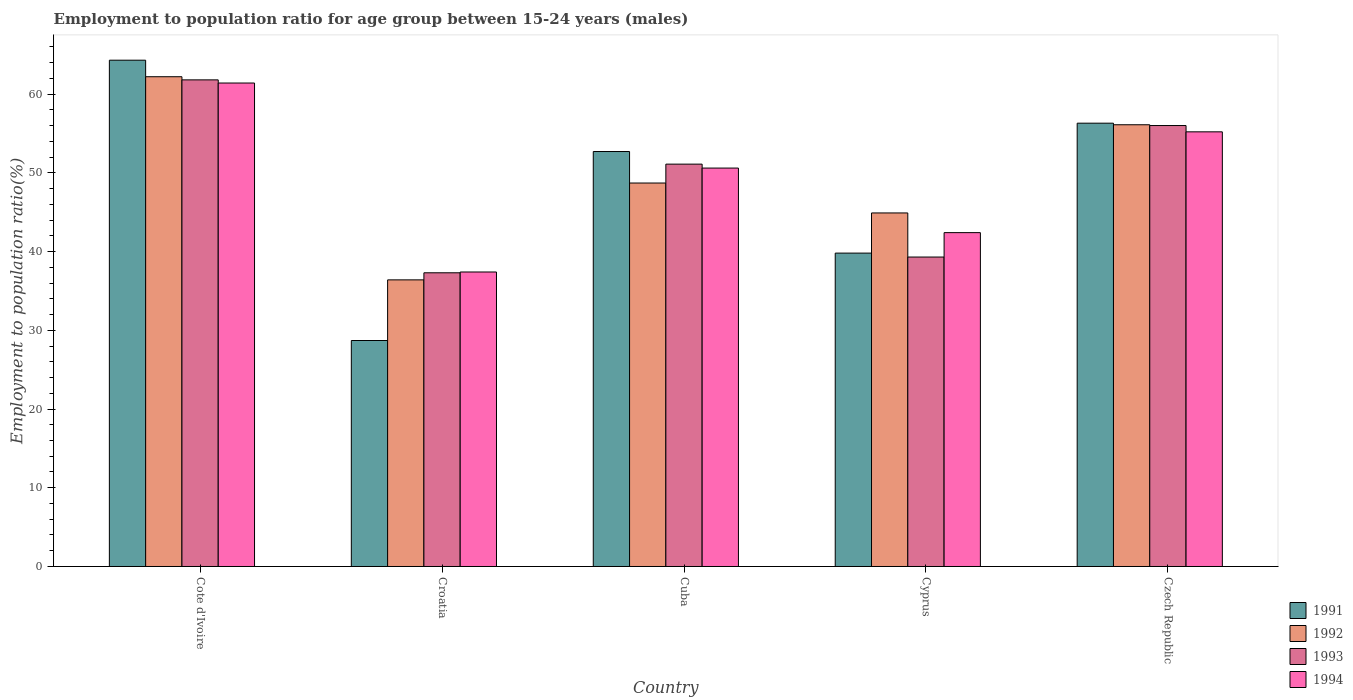How many different coloured bars are there?
Ensure brevity in your answer.  4. Are the number of bars on each tick of the X-axis equal?
Your answer should be very brief. Yes. How many bars are there on the 2nd tick from the right?
Ensure brevity in your answer.  4. What is the label of the 1st group of bars from the left?
Offer a very short reply. Cote d'Ivoire. What is the employment to population ratio in 1994 in Czech Republic?
Your answer should be very brief. 55.2. Across all countries, what is the maximum employment to population ratio in 1994?
Ensure brevity in your answer.  61.4. Across all countries, what is the minimum employment to population ratio in 1993?
Provide a succinct answer. 37.3. In which country was the employment to population ratio in 1993 maximum?
Keep it short and to the point. Cote d'Ivoire. In which country was the employment to population ratio in 1994 minimum?
Provide a succinct answer. Croatia. What is the total employment to population ratio in 1993 in the graph?
Ensure brevity in your answer.  245.5. What is the difference between the employment to population ratio in 1991 in Cote d'Ivoire and that in Croatia?
Provide a short and direct response. 35.6. What is the difference between the employment to population ratio in 1991 in Cuba and the employment to population ratio in 1993 in Czech Republic?
Keep it short and to the point. -3.3. What is the average employment to population ratio in 1992 per country?
Offer a terse response. 49.66. What is the difference between the employment to population ratio of/in 1992 and employment to population ratio of/in 1991 in Cuba?
Provide a short and direct response. -4. What is the ratio of the employment to population ratio in 1994 in Cote d'Ivoire to that in Croatia?
Ensure brevity in your answer.  1.64. Is the difference between the employment to population ratio in 1992 in Cyprus and Czech Republic greater than the difference between the employment to population ratio in 1991 in Cyprus and Czech Republic?
Offer a terse response. Yes. What is the difference between the highest and the second highest employment to population ratio in 1993?
Offer a very short reply. 4.9. What is the difference between the highest and the lowest employment to population ratio in 1993?
Your answer should be compact. 24.5. In how many countries, is the employment to population ratio in 1992 greater than the average employment to population ratio in 1992 taken over all countries?
Make the answer very short. 2. Is the sum of the employment to population ratio in 1992 in Cuba and Cyprus greater than the maximum employment to population ratio in 1994 across all countries?
Your response must be concise. Yes. What does the 4th bar from the right in Croatia represents?
Offer a terse response. 1991. Is it the case that in every country, the sum of the employment to population ratio in 1992 and employment to population ratio in 1991 is greater than the employment to population ratio in 1993?
Make the answer very short. Yes. How many bars are there?
Provide a short and direct response. 20. Does the graph contain grids?
Your answer should be compact. No. How many legend labels are there?
Offer a very short reply. 4. What is the title of the graph?
Your response must be concise. Employment to population ratio for age group between 15-24 years (males). What is the label or title of the X-axis?
Give a very brief answer. Country. What is the label or title of the Y-axis?
Give a very brief answer. Employment to population ratio(%). What is the Employment to population ratio(%) of 1991 in Cote d'Ivoire?
Provide a succinct answer. 64.3. What is the Employment to population ratio(%) of 1992 in Cote d'Ivoire?
Provide a succinct answer. 62.2. What is the Employment to population ratio(%) of 1993 in Cote d'Ivoire?
Offer a very short reply. 61.8. What is the Employment to population ratio(%) of 1994 in Cote d'Ivoire?
Offer a terse response. 61.4. What is the Employment to population ratio(%) in 1991 in Croatia?
Give a very brief answer. 28.7. What is the Employment to population ratio(%) in 1992 in Croatia?
Keep it short and to the point. 36.4. What is the Employment to population ratio(%) of 1993 in Croatia?
Keep it short and to the point. 37.3. What is the Employment to population ratio(%) in 1994 in Croatia?
Provide a succinct answer. 37.4. What is the Employment to population ratio(%) in 1991 in Cuba?
Provide a succinct answer. 52.7. What is the Employment to population ratio(%) of 1992 in Cuba?
Offer a very short reply. 48.7. What is the Employment to population ratio(%) of 1993 in Cuba?
Make the answer very short. 51.1. What is the Employment to population ratio(%) of 1994 in Cuba?
Provide a short and direct response. 50.6. What is the Employment to population ratio(%) in 1991 in Cyprus?
Provide a succinct answer. 39.8. What is the Employment to population ratio(%) of 1992 in Cyprus?
Provide a short and direct response. 44.9. What is the Employment to population ratio(%) in 1993 in Cyprus?
Keep it short and to the point. 39.3. What is the Employment to population ratio(%) of 1994 in Cyprus?
Keep it short and to the point. 42.4. What is the Employment to population ratio(%) of 1991 in Czech Republic?
Provide a short and direct response. 56.3. What is the Employment to population ratio(%) in 1992 in Czech Republic?
Ensure brevity in your answer.  56.1. What is the Employment to population ratio(%) of 1994 in Czech Republic?
Provide a succinct answer. 55.2. Across all countries, what is the maximum Employment to population ratio(%) of 1991?
Give a very brief answer. 64.3. Across all countries, what is the maximum Employment to population ratio(%) of 1992?
Your answer should be compact. 62.2. Across all countries, what is the maximum Employment to population ratio(%) of 1993?
Your answer should be very brief. 61.8. Across all countries, what is the maximum Employment to population ratio(%) of 1994?
Your response must be concise. 61.4. Across all countries, what is the minimum Employment to population ratio(%) of 1991?
Your answer should be very brief. 28.7. Across all countries, what is the minimum Employment to population ratio(%) of 1992?
Ensure brevity in your answer.  36.4. Across all countries, what is the minimum Employment to population ratio(%) of 1993?
Give a very brief answer. 37.3. Across all countries, what is the minimum Employment to population ratio(%) in 1994?
Provide a succinct answer. 37.4. What is the total Employment to population ratio(%) of 1991 in the graph?
Offer a very short reply. 241.8. What is the total Employment to population ratio(%) of 1992 in the graph?
Make the answer very short. 248.3. What is the total Employment to population ratio(%) in 1993 in the graph?
Keep it short and to the point. 245.5. What is the total Employment to population ratio(%) of 1994 in the graph?
Provide a succinct answer. 247. What is the difference between the Employment to population ratio(%) in 1991 in Cote d'Ivoire and that in Croatia?
Provide a short and direct response. 35.6. What is the difference between the Employment to population ratio(%) in 1992 in Cote d'Ivoire and that in Croatia?
Your answer should be very brief. 25.8. What is the difference between the Employment to population ratio(%) in 1993 in Cote d'Ivoire and that in Croatia?
Keep it short and to the point. 24.5. What is the difference between the Employment to population ratio(%) in 1994 in Cote d'Ivoire and that in Croatia?
Your answer should be compact. 24. What is the difference between the Employment to population ratio(%) in 1991 in Cote d'Ivoire and that in Cuba?
Make the answer very short. 11.6. What is the difference between the Employment to population ratio(%) of 1993 in Cote d'Ivoire and that in Cuba?
Ensure brevity in your answer.  10.7. What is the difference between the Employment to population ratio(%) of 1994 in Cote d'Ivoire and that in Cuba?
Offer a terse response. 10.8. What is the difference between the Employment to population ratio(%) of 1991 in Cote d'Ivoire and that in Cyprus?
Give a very brief answer. 24.5. What is the difference between the Employment to population ratio(%) in 1994 in Cote d'Ivoire and that in Cyprus?
Your response must be concise. 19. What is the difference between the Employment to population ratio(%) in 1991 in Cote d'Ivoire and that in Czech Republic?
Offer a terse response. 8. What is the difference between the Employment to population ratio(%) in 1994 in Cote d'Ivoire and that in Czech Republic?
Your response must be concise. 6.2. What is the difference between the Employment to population ratio(%) of 1992 in Croatia and that in Cuba?
Offer a terse response. -12.3. What is the difference between the Employment to population ratio(%) in 1993 in Croatia and that in Cuba?
Offer a terse response. -13.8. What is the difference between the Employment to population ratio(%) in 1991 in Croatia and that in Czech Republic?
Offer a terse response. -27.6. What is the difference between the Employment to population ratio(%) of 1992 in Croatia and that in Czech Republic?
Keep it short and to the point. -19.7. What is the difference between the Employment to population ratio(%) in 1993 in Croatia and that in Czech Republic?
Keep it short and to the point. -18.7. What is the difference between the Employment to population ratio(%) of 1994 in Croatia and that in Czech Republic?
Your response must be concise. -17.8. What is the difference between the Employment to population ratio(%) in 1993 in Cuba and that in Cyprus?
Your response must be concise. 11.8. What is the difference between the Employment to population ratio(%) in 1994 in Cuba and that in Cyprus?
Make the answer very short. 8.2. What is the difference between the Employment to population ratio(%) in 1991 in Cuba and that in Czech Republic?
Make the answer very short. -3.6. What is the difference between the Employment to population ratio(%) in 1992 in Cuba and that in Czech Republic?
Provide a succinct answer. -7.4. What is the difference between the Employment to population ratio(%) of 1993 in Cuba and that in Czech Republic?
Provide a short and direct response. -4.9. What is the difference between the Employment to population ratio(%) in 1994 in Cuba and that in Czech Republic?
Your answer should be very brief. -4.6. What is the difference between the Employment to population ratio(%) of 1991 in Cyprus and that in Czech Republic?
Keep it short and to the point. -16.5. What is the difference between the Employment to population ratio(%) of 1992 in Cyprus and that in Czech Republic?
Provide a succinct answer. -11.2. What is the difference between the Employment to population ratio(%) in 1993 in Cyprus and that in Czech Republic?
Your response must be concise. -16.7. What is the difference between the Employment to population ratio(%) of 1994 in Cyprus and that in Czech Republic?
Offer a very short reply. -12.8. What is the difference between the Employment to population ratio(%) in 1991 in Cote d'Ivoire and the Employment to population ratio(%) in 1992 in Croatia?
Your answer should be very brief. 27.9. What is the difference between the Employment to population ratio(%) of 1991 in Cote d'Ivoire and the Employment to population ratio(%) of 1993 in Croatia?
Your answer should be compact. 27. What is the difference between the Employment to population ratio(%) in 1991 in Cote d'Ivoire and the Employment to population ratio(%) in 1994 in Croatia?
Your answer should be very brief. 26.9. What is the difference between the Employment to population ratio(%) in 1992 in Cote d'Ivoire and the Employment to population ratio(%) in 1993 in Croatia?
Make the answer very short. 24.9. What is the difference between the Employment to population ratio(%) of 1992 in Cote d'Ivoire and the Employment to population ratio(%) of 1994 in Croatia?
Keep it short and to the point. 24.8. What is the difference between the Employment to population ratio(%) of 1993 in Cote d'Ivoire and the Employment to population ratio(%) of 1994 in Croatia?
Your response must be concise. 24.4. What is the difference between the Employment to population ratio(%) of 1992 in Cote d'Ivoire and the Employment to population ratio(%) of 1994 in Cuba?
Ensure brevity in your answer.  11.6. What is the difference between the Employment to population ratio(%) in 1991 in Cote d'Ivoire and the Employment to population ratio(%) in 1994 in Cyprus?
Give a very brief answer. 21.9. What is the difference between the Employment to population ratio(%) of 1992 in Cote d'Ivoire and the Employment to population ratio(%) of 1993 in Cyprus?
Provide a succinct answer. 22.9. What is the difference between the Employment to population ratio(%) of 1992 in Cote d'Ivoire and the Employment to population ratio(%) of 1994 in Cyprus?
Offer a very short reply. 19.8. What is the difference between the Employment to population ratio(%) of 1993 in Cote d'Ivoire and the Employment to population ratio(%) of 1994 in Cyprus?
Make the answer very short. 19.4. What is the difference between the Employment to population ratio(%) in 1991 in Cote d'Ivoire and the Employment to population ratio(%) in 1992 in Czech Republic?
Give a very brief answer. 8.2. What is the difference between the Employment to population ratio(%) of 1991 in Cote d'Ivoire and the Employment to population ratio(%) of 1993 in Czech Republic?
Give a very brief answer. 8.3. What is the difference between the Employment to population ratio(%) in 1991 in Cote d'Ivoire and the Employment to population ratio(%) in 1994 in Czech Republic?
Your answer should be very brief. 9.1. What is the difference between the Employment to population ratio(%) of 1992 in Cote d'Ivoire and the Employment to population ratio(%) of 1993 in Czech Republic?
Offer a very short reply. 6.2. What is the difference between the Employment to population ratio(%) in 1992 in Cote d'Ivoire and the Employment to population ratio(%) in 1994 in Czech Republic?
Give a very brief answer. 7. What is the difference between the Employment to population ratio(%) in 1991 in Croatia and the Employment to population ratio(%) in 1993 in Cuba?
Your answer should be very brief. -22.4. What is the difference between the Employment to population ratio(%) in 1991 in Croatia and the Employment to population ratio(%) in 1994 in Cuba?
Offer a very short reply. -21.9. What is the difference between the Employment to population ratio(%) in 1992 in Croatia and the Employment to population ratio(%) in 1993 in Cuba?
Provide a short and direct response. -14.7. What is the difference between the Employment to population ratio(%) of 1991 in Croatia and the Employment to population ratio(%) of 1992 in Cyprus?
Your response must be concise. -16.2. What is the difference between the Employment to population ratio(%) of 1991 in Croatia and the Employment to population ratio(%) of 1994 in Cyprus?
Keep it short and to the point. -13.7. What is the difference between the Employment to population ratio(%) of 1992 in Croatia and the Employment to population ratio(%) of 1993 in Cyprus?
Provide a short and direct response. -2.9. What is the difference between the Employment to population ratio(%) in 1991 in Croatia and the Employment to population ratio(%) in 1992 in Czech Republic?
Your answer should be very brief. -27.4. What is the difference between the Employment to population ratio(%) of 1991 in Croatia and the Employment to population ratio(%) of 1993 in Czech Republic?
Your answer should be compact. -27.3. What is the difference between the Employment to population ratio(%) in 1991 in Croatia and the Employment to population ratio(%) in 1994 in Czech Republic?
Your answer should be very brief. -26.5. What is the difference between the Employment to population ratio(%) of 1992 in Croatia and the Employment to population ratio(%) of 1993 in Czech Republic?
Your response must be concise. -19.6. What is the difference between the Employment to population ratio(%) in 1992 in Croatia and the Employment to population ratio(%) in 1994 in Czech Republic?
Your answer should be compact. -18.8. What is the difference between the Employment to population ratio(%) in 1993 in Croatia and the Employment to population ratio(%) in 1994 in Czech Republic?
Ensure brevity in your answer.  -17.9. What is the difference between the Employment to population ratio(%) of 1991 in Cuba and the Employment to population ratio(%) of 1993 in Cyprus?
Offer a terse response. 13.4. What is the difference between the Employment to population ratio(%) of 1991 in Cuba and the Employment to population ratio(%) of 1994 in Cyprus?
Provide a succinct answer. 10.3. What is the difference between the Employment to population ratio(%) in 1992 in Cuba and the Employment to population ratio(%) in 1993 in Cyprus?
Give a very brief answer. 9.4. What is the difference between the Employment to population ratio(%) of 1991 in Cuba and the Employment to population ratio(%) of 1994 in Czech Republic?
Provide a succinct answer. -2.5. What is the difference between the Employment to population ratio(%) of 1992 in Cuba and the Employment to population ratio(%) of 1994 in Czech Republic?
Give a very brief answer. -6.5. What is the difference between the Employment to population ratio(%) in 1991 in Cyprus and the Employment to population ratio(%) in 1992 in Czech Republic?
Ensure brevity in your answer.  -16.3. What is the difference between the Employment to population ratio(%) of 1991 in Cyprus and the Employment to population ratio(%) of 1993 in Czech Republic?
Keep it short and to the point. -16.2. What is the difference between the Employment to population ratio(%) of 1991 in Cyprus and the Employment to population ratio(%) of 1994 in Czech Republic?
Offer a terse response. -15.4. What is the difference between the Employment to population ratio(%) in 1992 in Cyprus and the Employment to population ratio(%) in 1993 in Czech Republic?
Your answer should be compact. -11.1. What is the difference between the Employment to population ratio(%) of 1993 in Cyprus and the Employment to population ratio(%) of 1994 in Czech Republic?
Give a very brief answer. -15.9. What is the average Employment to population ratio(%) in 1991 per country?
Offer a very short reply. 48.36. What is the average Employment to population ratio(%) of 1992 per country?
Your answer should be very brief. 49.66. What is the average Employment to population ratio(%) of 1993 per country?
Provide a succinct answer. 49.1. What is the average Employment to population ratio(%) in 1994 per country?
Offer a terse response. 49.4. What is the difference between the Employment to population ratio(%) in 1991 and Employment to population ratio(%) in 1992 in Cote d'Ivoire?
Make the answer very short. 2.1. What is the difference between the Employment to population ratio(%) of 1991 and Employment to population ratio(%) of 1993 in Cote d'Ivoire?
Give a very brief answer. 2.5. What is the difference between the Employment to population ratio(%) of 1992 and Employment to population ratio(%) of 1993 in Cote d'Ivoire?
Offer a terse response. 0.4. What is the difference between the Employment to population ratio(%) in 1993 and Employment to population ratio(%) in 1994 in Cote d'Ivoire?
Make the answer very short. 0.4. What is the difference between the Employment to population ratio(%) in 1991 and Employment to population ratio(%) in 1992 in Croatia?
Your answer should be very brief. -7.7. What is the difference between the Employment to population ratio(%) in 1991 and Employment to population ratio(%) in 1993 in Croatia?
Your response must be concise. -8.6. What is the difference between the Employment to population ratio(%) in 1991 and Employment to population ratio(%) in 1994 in Croatia?
Offer a terse response. -8.7. What is the difference between the Employment to population ratio(%) in 1993 and Employment to population ratio(%) in 1994 in Croatia?
Provide a succinct answer. -0.1. What is the difference between the Employment to population ratio(%) of 1991 and Employment to population ratio(%) of 1992 in Cuba?
Ensure brevity in your answer.  4. What is the difference between the Employment to population ratio(%) in 1991 and Employment to population ratio(%) in 1993 in Cuba?
Keep it short and to the point. 1.6. What is the difference between the Employment to population ratio(%) in 1991 and Employment to population ratio(%) in 1994 in Cuba?
Make the answer very short. 2.1. What is the difference between the Employment to population ratio(%) of 1992 and Employment to population ratio(%) of 1993 in Cuba?
Keep it short and to the point. -2.4. What is the difference between the Employment to population ratio(%) in 1992 and Employment to population ratio(%) in 1994 in Cuba?
Offer a very short reply. -1.9. What is the difference between the Employment to population ratio(%) of 1991 and Employment to population ratio(%) of 1992 in Cyprus?
Your answer should be very brief. -5.1. What is the difference between the Employment to population ratio(%) in 1992 and Employment to population ratio(%) in 1993 in Cyprus?
Give a very brief answer. 5.6. What is the difference between the Employment to population ratio(%) in 1992 and Employment to population ratio(%) in 1994 in Cyprus?
Your response must be concise. 2.5. What is the difference between the Employment to population ratio(%) in 1993 and Employment to population ratio(%) in 1994 in Cyprus?
Make the answer very short. -3.1. What is the difference between the Employment to population ratio(%) in 1991 and Employment to population ratio(%) in 1992 in Czech Republic?
Your answer should be compact. 0.2. What is the difference between the Employment to population ratio(%) of 1991 and Employment to population ratio(%) of 1993 in Czech Republic?
Provide a short and direct response. 0.3. What is the ratio of the Employment to population ratio(%) in 1991 in Cote d'Ivoire to that in Croatia?
Offer a terse response. 2.24. What is the ratio of the Employment to population ratio(%) in 1992 in Cote d'Ivoire to that in Croatia?
Provide a short and direct response. 1.71. What is the ratio of the Employment to population ratio(%) in 1993 in Cote d'Ivoire to that in Croatia?
Your answer should be compact. 1.66. What is the ratio of the Employment to population ratio(%) of 1994 in Cote d'Ivoire to that in Croatia?
Your response must be concise. 1.64. What is the ratio of the Employment to population ratio(%) in 1991 in Cote d'Ivoire to that in Cuba?
Your response must be concise. 1.22. What is the ratio of the Employment to population ratio(%) in 1992 in Cote d'Ivoire to that in Cuba?
Make the answer very short. 1.28. What is the ratio of the Employment to population ratio(%) of 1993 in Cote d'Ivoire to that in Cuba?
Your answer should be compact. 1.21. What is the ratio of the Employment to population ratio(%) of 1994 in Cote d'Ivoire to that in Cuba?
Your answer should be compact. 1.21. What is the ratio of the Employment to population ratio(%) of 1991 in Cote d'Ivoire to that in Cyprus?
Give a very brief answer. 1.62. What is the ratio of the Employment to population ratio(%) in 1992 in Cote d'Ivoire to that in Cyprus?
Your response must be concise. 1.39. What is the ratio of the Employment to population ratio(%) in 1993 in Cote d'Ivoire to that in Cyprus?
Offer a terse response. 1.57. What is the ratio of the Employment to population ratio(%) in 1994 in Cote d'Ivoire to that in Cyprus?
Offer a very short reply. 1.45. What is the ratio of the Employment to population ratio(%) in 1991 in Cote d'Ivoire to that in Czech Republic?
Provide a succinct answer. 1.14. What is the ratio of the Employment to population ratio(%) of 1992 in Cote d'Ivoire to that in Czech Republic?
Offer a terse response. 1.11. What is the ratio of the Employment to population ratio(%) in 1993 in Cote d'Ivoire to that in Czech Republic?
Your answer should be compact. 1.1. What is the ratio of the Employment to population ratio(%) in 1994 in Cote d'Ivoire to that in Czech Republic?
Your answer should be compact. 1.11. What is the ratio of the Employment to population ratio(%) in 1991 in Croatia to that in Cuba?
Your answer should be compact. 0.54. What is the ratio of the Employment to population ratio(%) of 1992 in Croatia to that in Cuba?
Keep it short and to the point. 0.75. What is the ratio of the Employment to population ratio(%) in 1993 in Croatia to that in Cuba?
Provide a succinct answer. 0.73. What is the ratio of the Employment to population ratio(%) in 1994 in Croatia to that in Cuba?
Keep it short and to the point. 0.74. What is the ratio of the Employment to population ratio(%) in 1991 in Croatia to that in Cyprus?
Keep it short and to the point. 0.72. What is the ratio of the Employment to population ratio(%) of 1992 in Croatia to that in Cyprus?
Give a very brief answer. 0.81. What is the ratio of the Employment to population ratio(%) of 1993 in Croatia to that in Cyprus?
Your response must be concise. 0.95. What is the ratio of the Employment to population ratio(%) in 1994 in Croatia to that in Cyprus?
Offer a very short reply. 0.88. What is the ratio of the Employment to population ratio(%) of 1991 in Croatia to that in Czech Republic?
Give a very brief answer. 0.51. What is the ratio of the Employment to population ratio(%) of 1992 in Croatia to that in Czech Republic?
Make the answer very short. 0.65. What is the ratio of the Employment to population ratio(%) in 1993 in Croatia to that in Czech Republic?
Give a very brief answer. 0.67. What is the ratio of the Employment to population ratio(%) of 1994 in Croatia to that in Czech Republic?
Keep it short and to the point. 0.68. What is the ratio of the Employment to population ratio(%) in 1991 in Cuba to that in Cyprus?
Offer a terse response. 1.32. What is the ratio of the Employment to population ratio(%) in 1992 in Cuba to that in Cyprus?
Offer a terse response. 1.08. What is the ratio of the Employment to population ratio(%) of 1993 in Cuba to that in Cyprus?
Keep it short and to the point. 1.3. What is the ratio of the Employment to population ratio(%) of 1994 in Cuba to that in Cyprus?
Your response must be concise. 1.19. What is the ratio of the Employment to population ratio(%) of 1991 in Cuba to that in Czech Republic?
Keep it short and to the point. 0.94. What is the ratio of the Employment to population ratio(%) of 1992 in Cuba to that in Czech Republic?
Make the answer very short. 0.87. What is the ratio of the Employment to population ratio(%) of 1993 in Cuba to that in Czech Republic?
Offer a very short reply. 0.91. What is the ratio of the Employment to population ratio(%) of 1991 in Cyprus to that in Czech Republic?
Keep it short and to the point. 0.71. What is the ratio of the Employment to population ratio(%) of 1992 in Cyprus to that in Czech Republic?
Make the answer very short. 0.8. What is the ratio of the Employment to population ratio(%) in 1993 in Cyprus to that in Czech Republic?
Give a very brief answer. 0.7. What is the ratio of the Employment to population ratio(%) in 1994 in Cyprus to that in Czech Republic?
Keep it short and to the point. 0.77. What is the difference between the highest and the second highest Employment to population ratio(%) of 1991?
Make the answer very short. 8. What is the difference between the highest and the second highest Employment to population ratio(%) of 1992?
Offer a very short reply. 6.1. What is the difference between the highest and the lowest Employment to population ratio(%) of 1991?
Give a very brief answer. 35.6. What is the difference between the highest and the lowest Employment to population ratio(%) of 1992?
Your answer should be very brief. 25.8. What is the difference between the highest and the lowest Employment to population ratio(%) in 1993?
Ensure brevity in your answer.  24.5. 